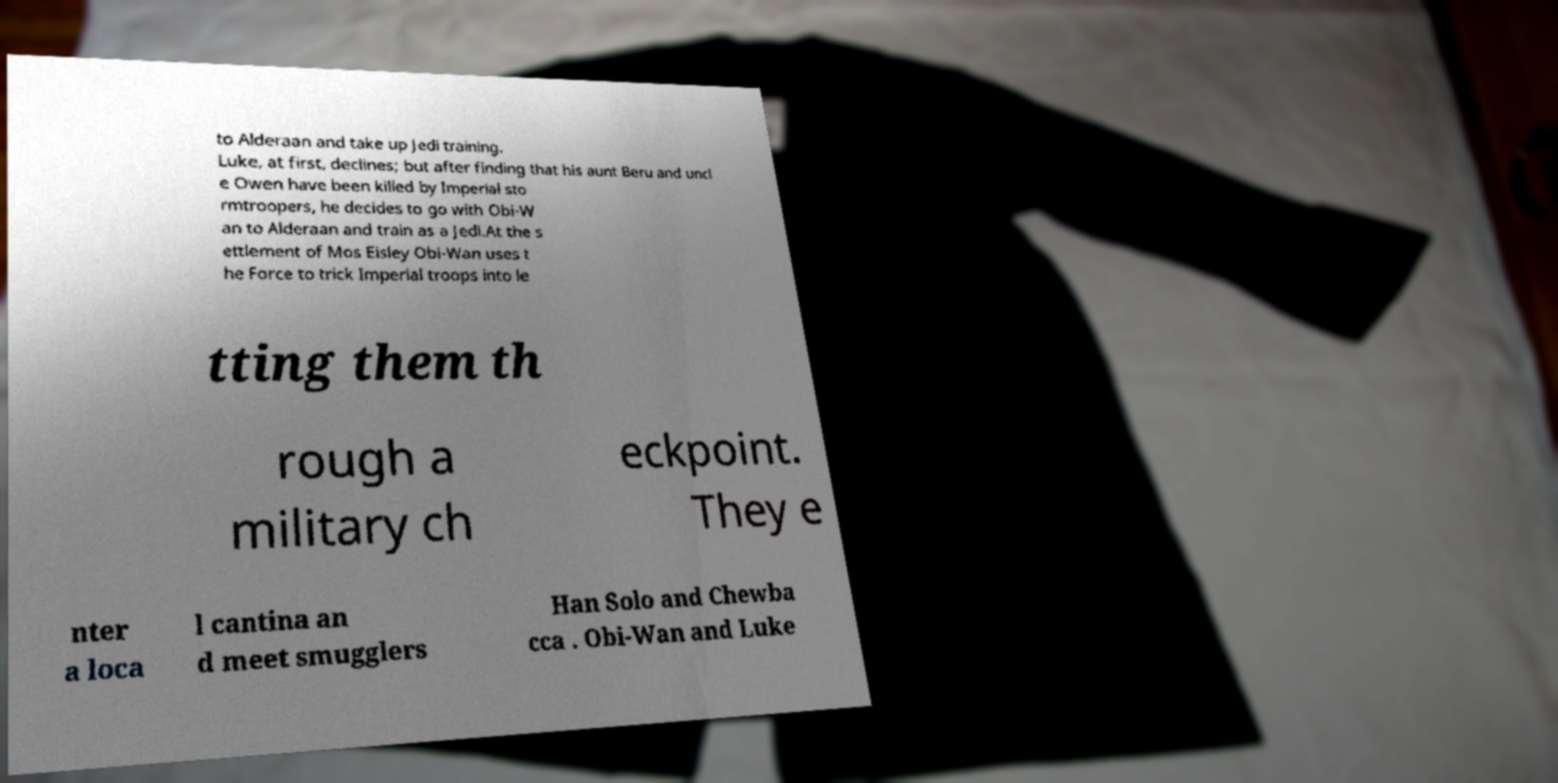I need the written content from this picture converted into text. Can you do that? to Alderaan and take up Jedi training. Luke, at first, declines; but after finding that his aunt Beru and uncl e Owen have been killed by Imperial sto rmtroopers, he decides to go with Obi-W an to Alderaan and train as a Jedi.At the s ettlement of Mos Eisley Obi-Wan uses t he Force to trick Imperial troops into le tting them th rough a military ch eckpoint. They e nter a loca l cantina an d meet smugglers Han Solo and Chewba cca . Obi-Wan and Luke 